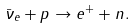Convert formula to latex. <formula><loc_0><loc_0><loc_500><loc_500>\bar { \nu } _ { e } + p \rightarrow e ^ { + } + n .</formula> 